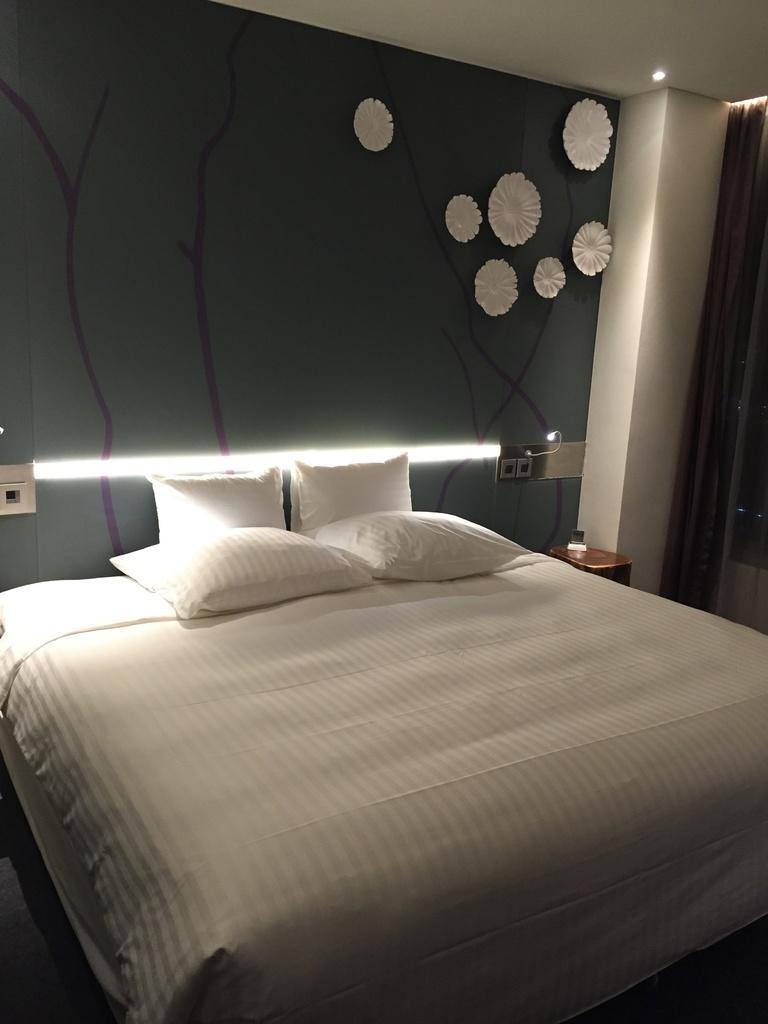Describe this image in one or two sentences. This is an inside view of a room. Here I can see a bed on which few pillows are placed. In the background there is a wall and pillar. On the right side there is a curtain to the window. Beside the bed there is a table. There is a light and a switch board are attached to the wall. 